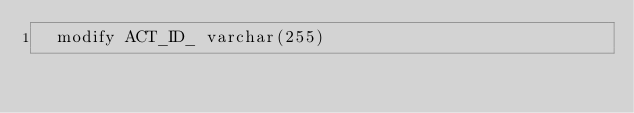Convert code to text. <code><loc_0><loc_0><loc_500><loc_500><_SQL_>  modify ACT_ID_ varchar(255)</code> 